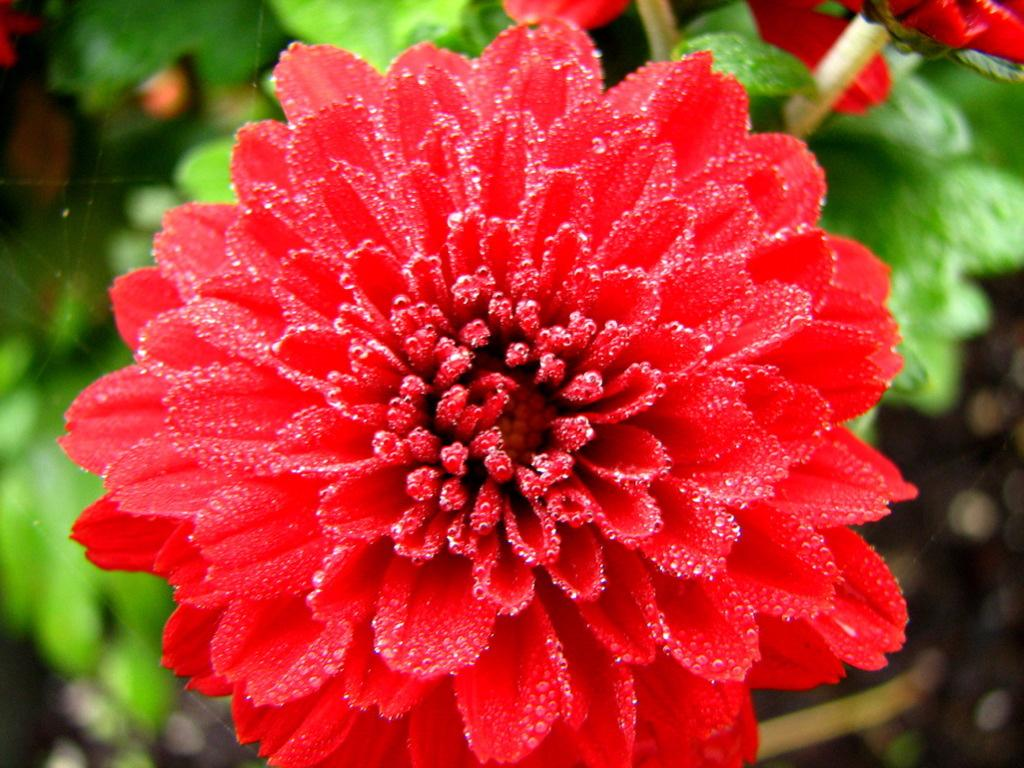What is the main subject of the image? There is a flower in the image in the image. Can you describe the background of the image? There is a plant in the background of the image. What type of shock can be seen in the image? There is no shock present in the image; it features a flower and a plant in the background. What type of lace can be seen on the flower in the image? There is no lace present on the flower in the image; it is a natural flower without any additional decorations. 